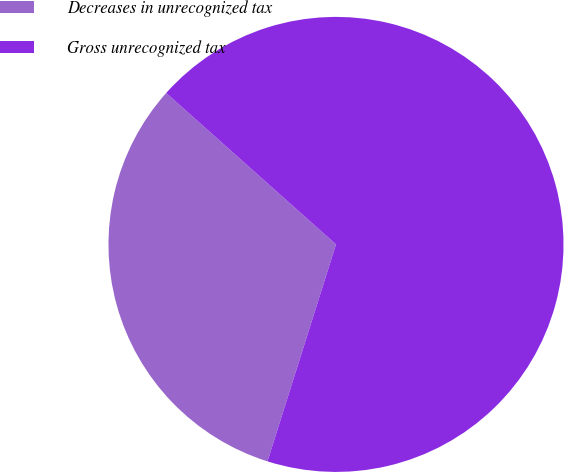Convert chart. <chart><loc_0><loc_0><loc_500><loc_500><pie_chart><fcel>Decreases in unrecognized tax<fcel>Gross unrecognized tax<nl><fcel>31.72%<fcel>68.28%<nl></chart> 